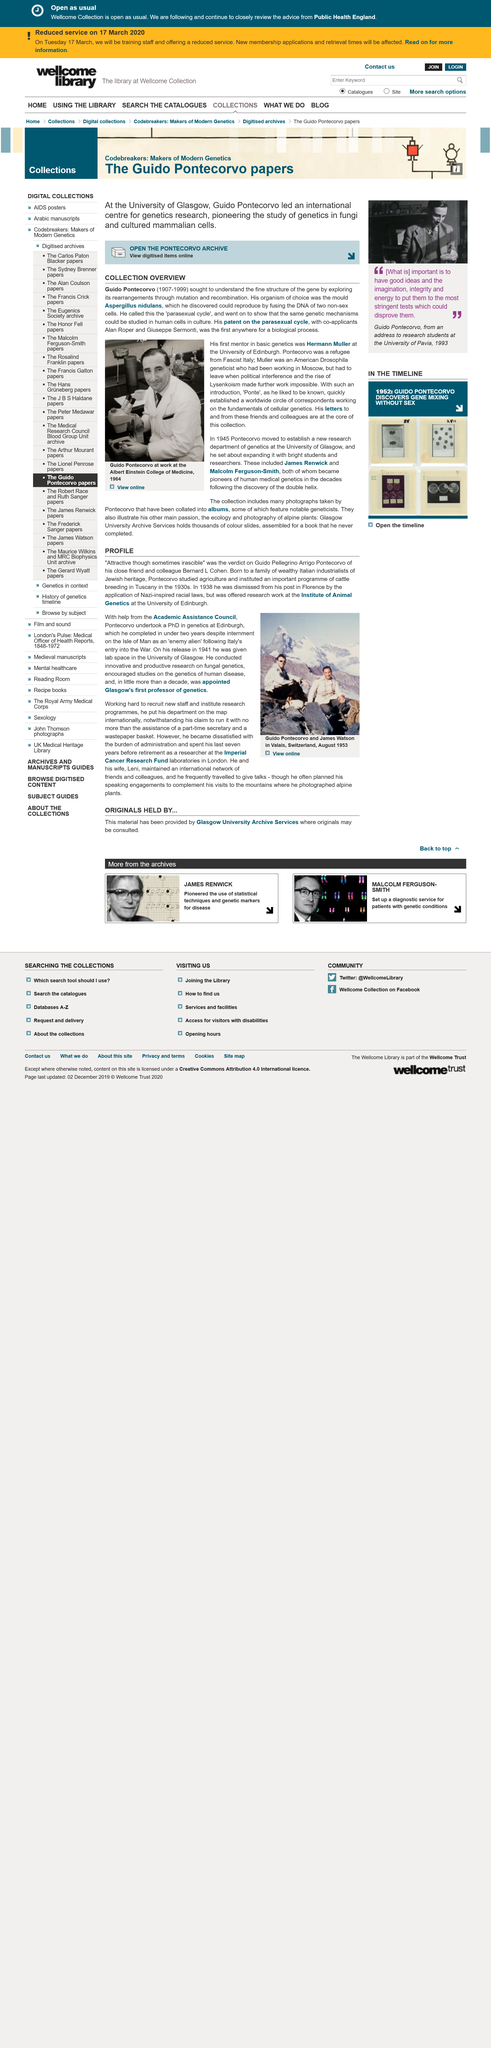Outline some significant characteristics in this image. Guido Pontecorvo was born in 1907. Pontecorvo undertook his PhD in genetics at the University of Edinburgh. Pontecorvo completed his PhD in under two years. Guido Pellegrino Arrigo Pontecorvo was found to be attractive by his close friend and colleague Bernard L Cohen, despite his occasional outbursts of irritability. Guido Pontecorvo died in 1999. 